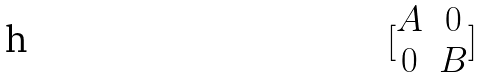Convert formula to latex. <formula><loc_0><loc_0><loc_500><loc_500>[ \begin{matrix} A & 0 \\ 0 & B \end{matrix} ]</formula> 